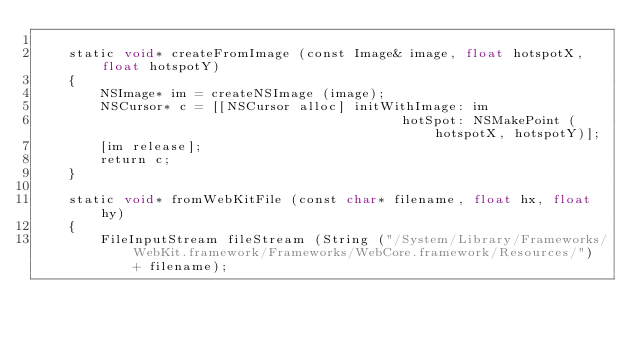<code> <loc_0><loc_0><loc_500><loc_500><_ObjectiveC_>
    static void* createFromImage (const Image& image, float hotspotX, float hotspotY)
    {
        NSImage* im = createNSImage (image);
        NSCursor* c = [[NSCursor alloc] initWithImage: im
                                              hotSpot: NSMakePoint (hotspotX, hotspotY)];
        [im release];
        return c;
    }

    static void* fromWebKitFile (const char* filename, float hx, float hy)
    {
        FileInputStream fileStream (String ("/System/Library/Frameworks/WebKit.framework/Frameworks/WebCore.framework/Resources/") + filename);</code> 